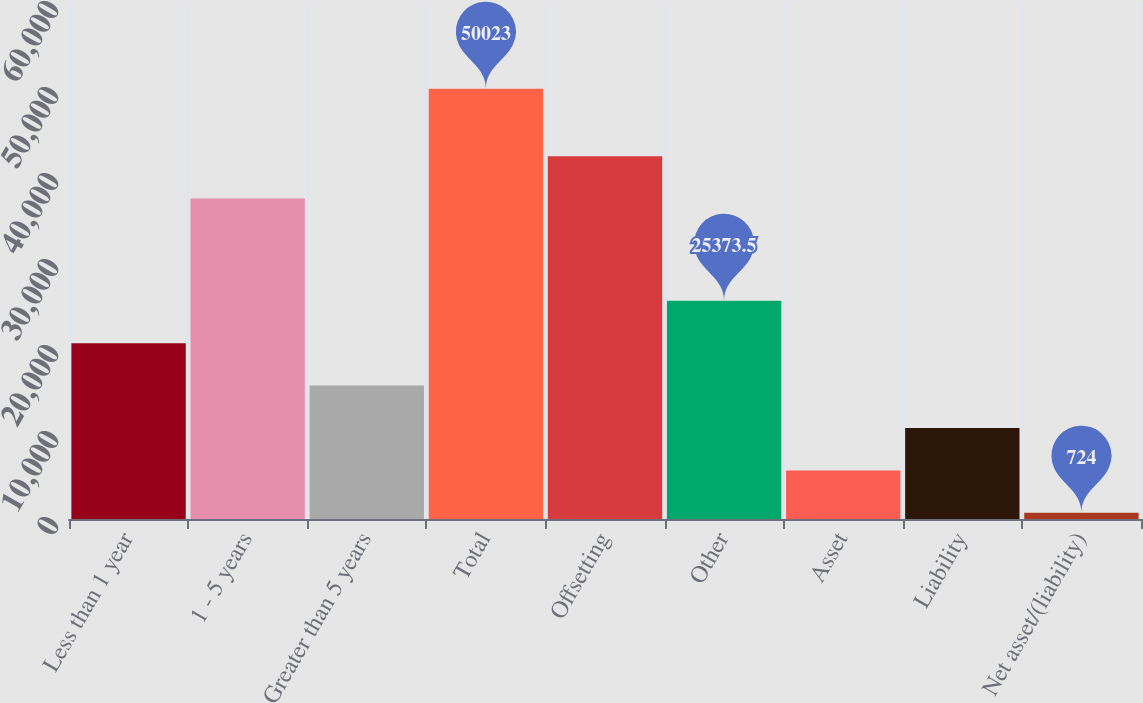<chart> <loc_0><loc_0><loc_500><loc_500><bar_chart><fcel>Less than 1 year<fcel>1 - 5 years<fcel>Greater than 5 years<fcel>Total<fcel>Offsetting<fcel>Other<fcel>Asset<fcel>Liability<fcel>Net asset/(liability)<nl><fcel>20443.6<fcel>37255<fcel>15513.7<fcel>50023<fcel>42184.9<fcel>25373.5<fcel>5653.9<fcel>10583.8<fcel>724<nl></chart> 